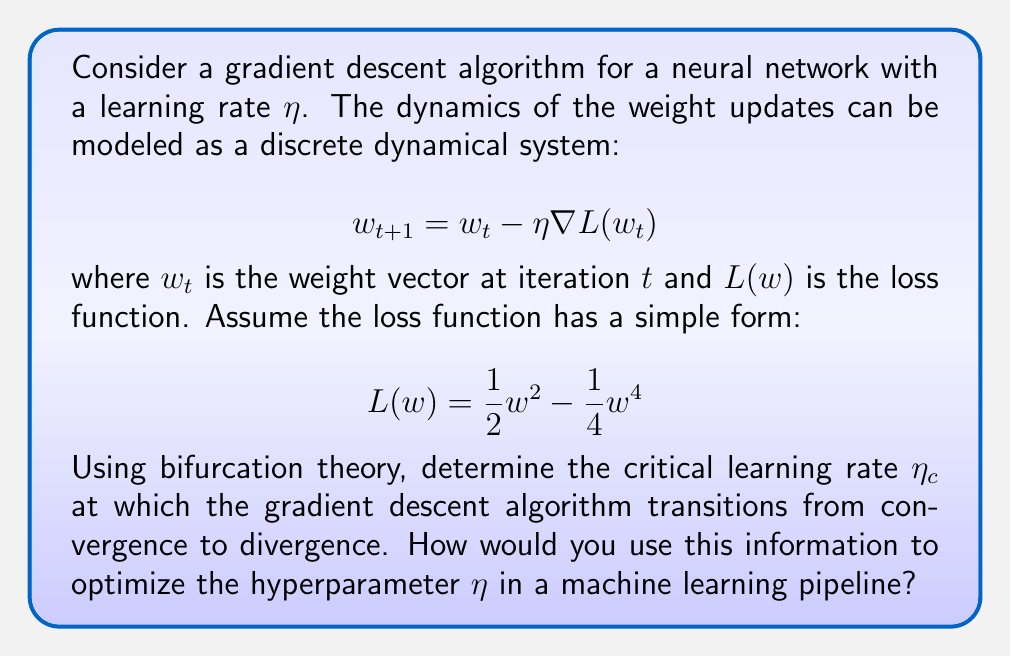Provide a solution to this math problem. To solve this problem, we'll follow these steps:

1) First, we need to express our dynamical system in terms of the given loss function:

   $$w_{t+1} = w_t - \eta \frac{dL}{dw} = w_t - \eta (w_t - w_t^3)$$

2) To find the fixed points of this system, we set $w_{t+1} = w_t = w^*$:

   $$w^* = w^* - \eta (w^* - (w^*)^3)$$

3) Solving this equation, we get three fixed points:

   $$w^* = 0, \pm 1$$

4) To determine the stability of these fixed points, we need to calculate the derivative of the update rule with respect to $w_t$:

   $$\frac{d}{dw_t}(w_t - \eta (w_t - w_t^3)) = 1 - \eta (1 - 3w_t^2)$$

5) For the fixed point $w^* = 0$, the stability condition is:

   $$|-\eta + 1| < 1$$

   This gives us the range for $\eta$: $0 < \eta < 2$

6) For the fixed points $w^* = \pm 1$, the stability condition is:

   $$|1 - \eta (1 - 3)| = |1 + 2\eta| < 1$$

   This gives us the range for $\eta$: $0 < \eta < 1$

7) The critical learning rate $\eta_c$ is the value at which the stability of the fixed points changes. This occurs at $\eta_c = 1$.

8) To optimize the hyperparameter $\eta$ in a machine learning pipeline:
   - Use $\eta_c = 1$ as an upper bound for the learning rate.
   - Implement a learning rate scheduler that starts with a value close to but below $\eta_c$ (e.g., 0.9) and gradually decreases it.
   - Monitor the convergence behavior of the algorithm and adjust the learning rate accordingly.
   - Use techniques like learning rate warm-up to stabilize training in the early stages.
   - Consider adaptive learning rate methods like Adam or RMSprop that automatically adjust the effective learning rate based on the gradient statistics.
Answer: $\eta_c = 1$ 